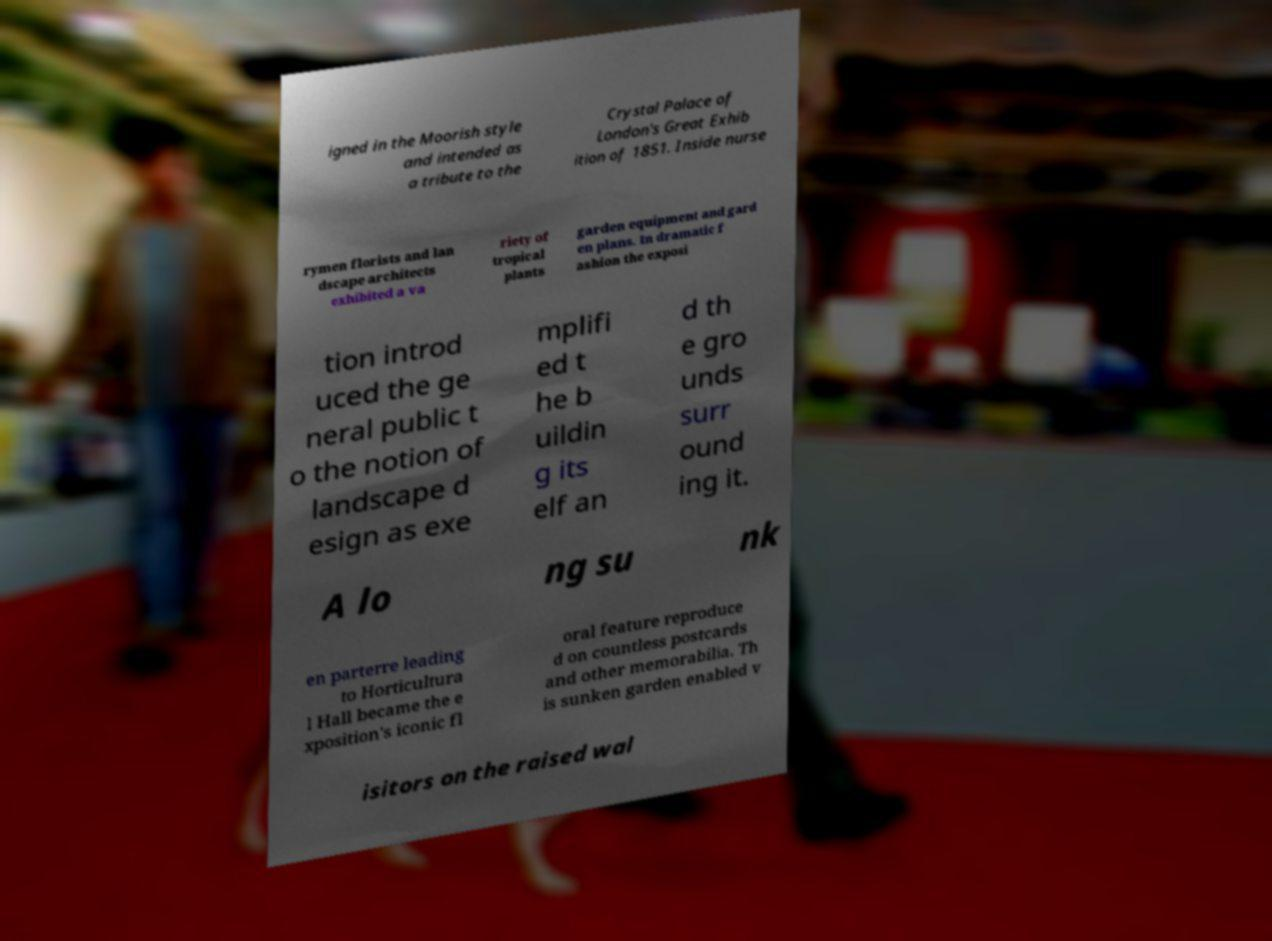Could you extract and type out the text from this image? igned in the Moorish style and intended as a tribute to the Crystal Palace of London's Great Exhib ition of 1851. Inside nurse rymen florists and lan dscape architects exhibited a va riety of tropical plants garden equipment and gard en plans. In dramatic f ashion the exposi tion introd uced the ge neral public t o the notion of landscape d esign as exe mplifi ed t he b uildin g its elf an d th e gro unds surr ound ing it. A lo ng su nk en parterre leading to Horticultura l Hall became the e xposition's iconic fl oral feature reproduce d on countless postcards and other memorabilia. Th is sunken garden enabled v isitors on the raised wal 